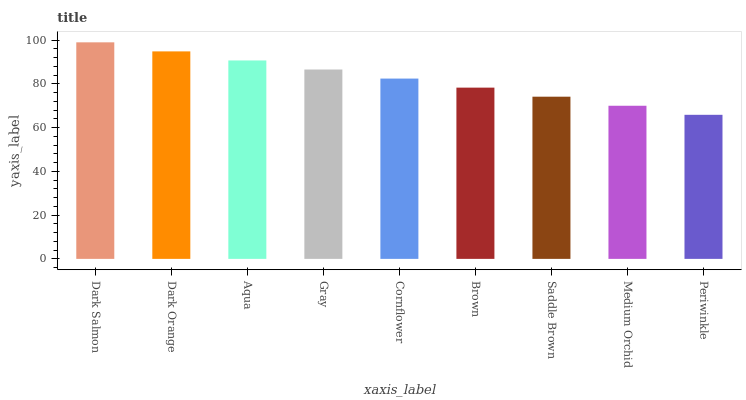Is Periwinkle the minimum?
Answer yes or no. Yes. Is Dark Salmon the maximum?
Answer yes or no. Yes. Is Dark Orange the minimum?
Answer yes or no. No. Is Dark Orange the maximum?
Answer yes or no. No. Is Dark Salmon greater than Dark Orange?
Answer yes or no. Yes. Is Dark Orange less than Dark Salmon?
Answer yes or no. Yes. Is Dark Orange greater than Dark Salmon?
Answer yes or no. No. Is Dark Salmon less than Dark Orange?
Answer yes or no. No. Is Cornflower the high median?
Answer yes or no. Yes. Is Cornflower the low median?
Answer yes or no. Yes. Is Dark Orange the high median?
Answer yes or no. No. Is Periwinkle the low median?
Answer yes or no. No. 